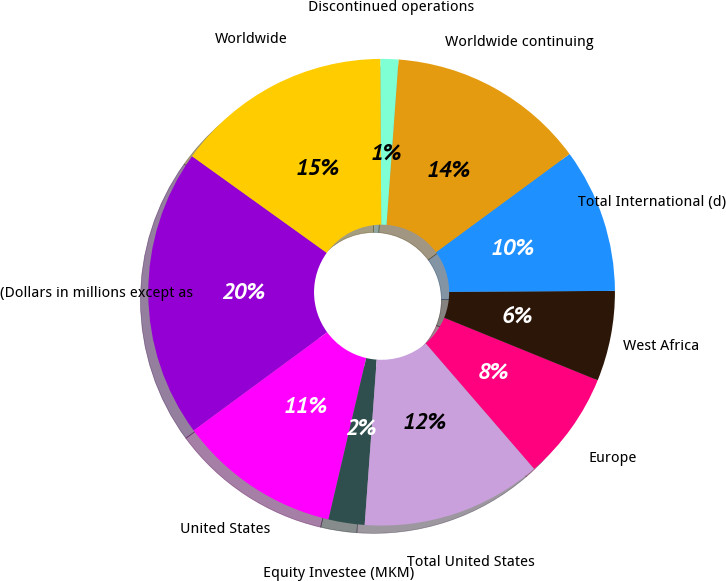<chart> <loc_0><loc_0><loc_500><loc_500><pie_chart><fcel>(Dollars in millions except as<fcel>United States<fcel>Equity Investee (MKM)<fcel>Total United States<fcel>Europe<fcel>West Africa<fcel>Total International (d)<fcel>Worldwide continuing<fcel>Discontinued operations<fcel>Worldwide<nl><fcel>20.0%<fcel>11.25%<fcel>2.5%<fcel>12.5%<fcel>7.5%<fcel>6.25%<fcel>10.0%<fcel>13.75%<fcel>1.25%<fcel>15.0%<nl></chart> 